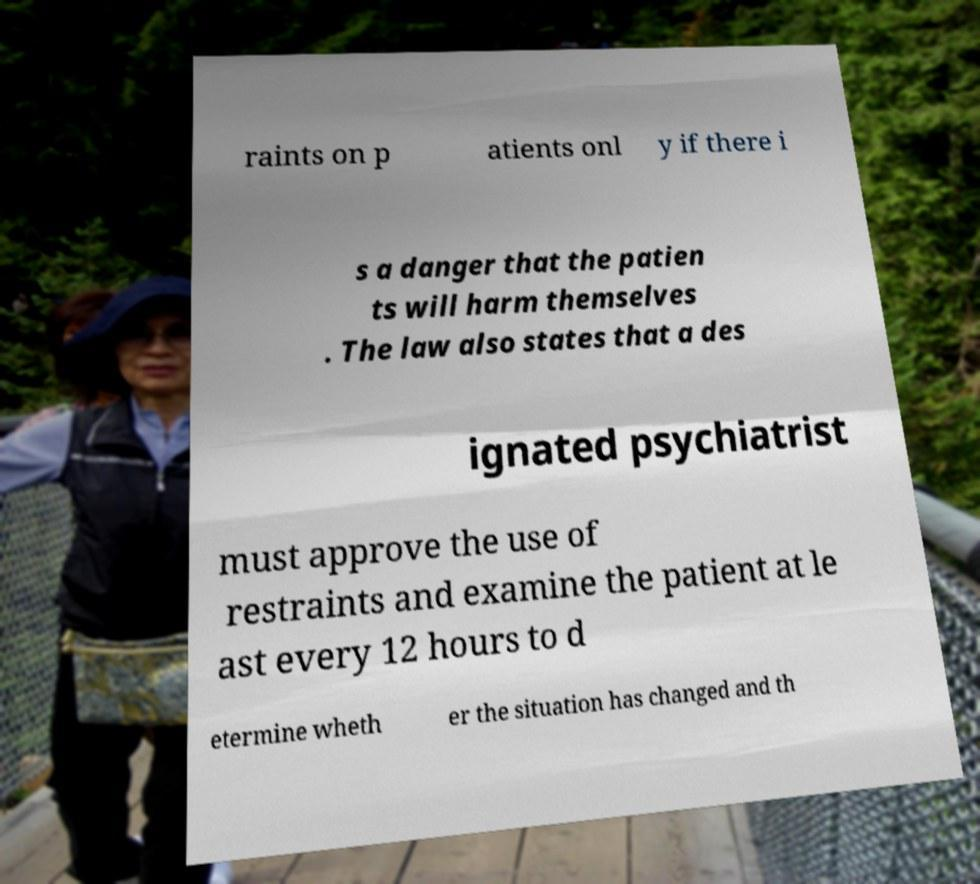I need the written content from this picture converted into text. Can you do that? raints on p atients onl y if there i s a danger that the patien ts will harm themselves . The law also states that a des ignated psychiatrist must approve the use of restraints and examine the patient at le ast every 12 hours to d etermine wheth er the situation has changed and th 